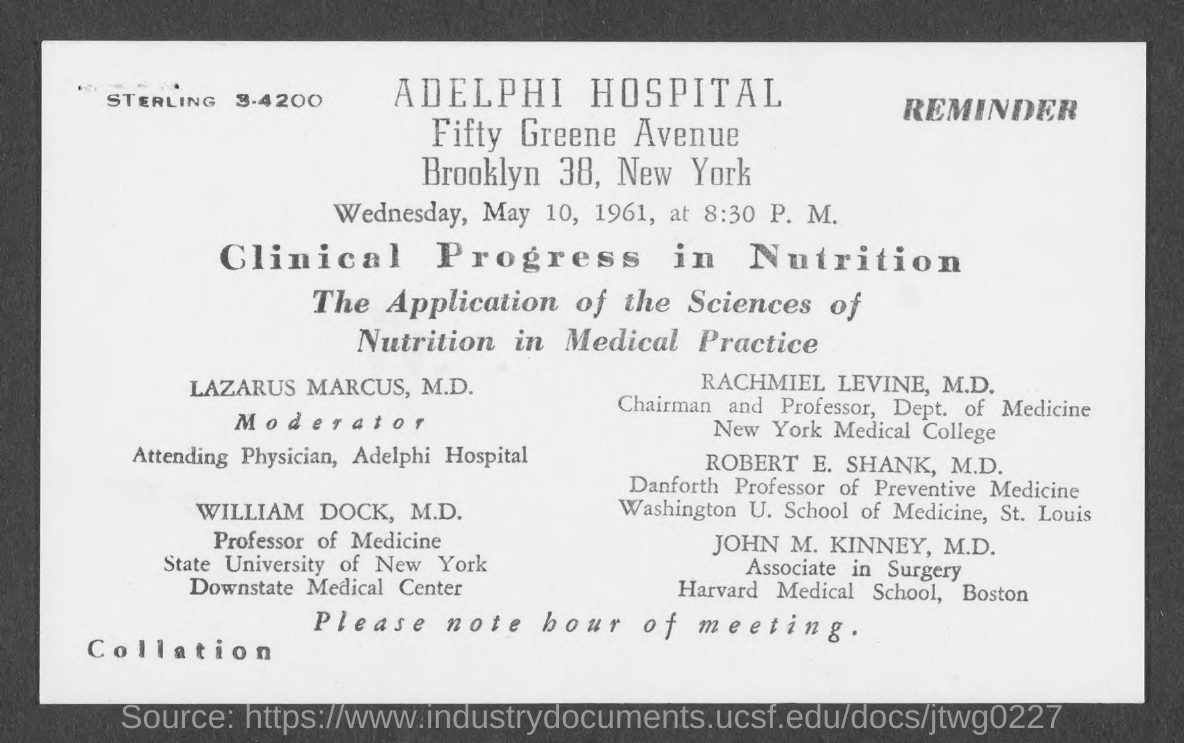When is the meeting?
Keep it short and to the point. Wednesday, May 10, 1961. What time is the meeting?
Offer a very short reply. 8:30 P.M. What is the title of the meeting?
Give a very brief answer. Clinical Progress in Nutrition. Who is the Moderator?
Give a very brief answer. Lazarus Marcus, M.D. 